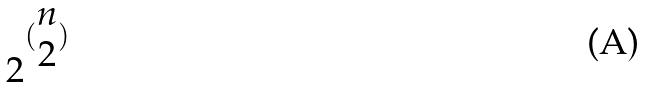<formula> <loc_0><loc_0><loc_500><loc_500>2 ^ { ( \begin{matrix} n \\ 2 \end{matrix} ) }</formula> 